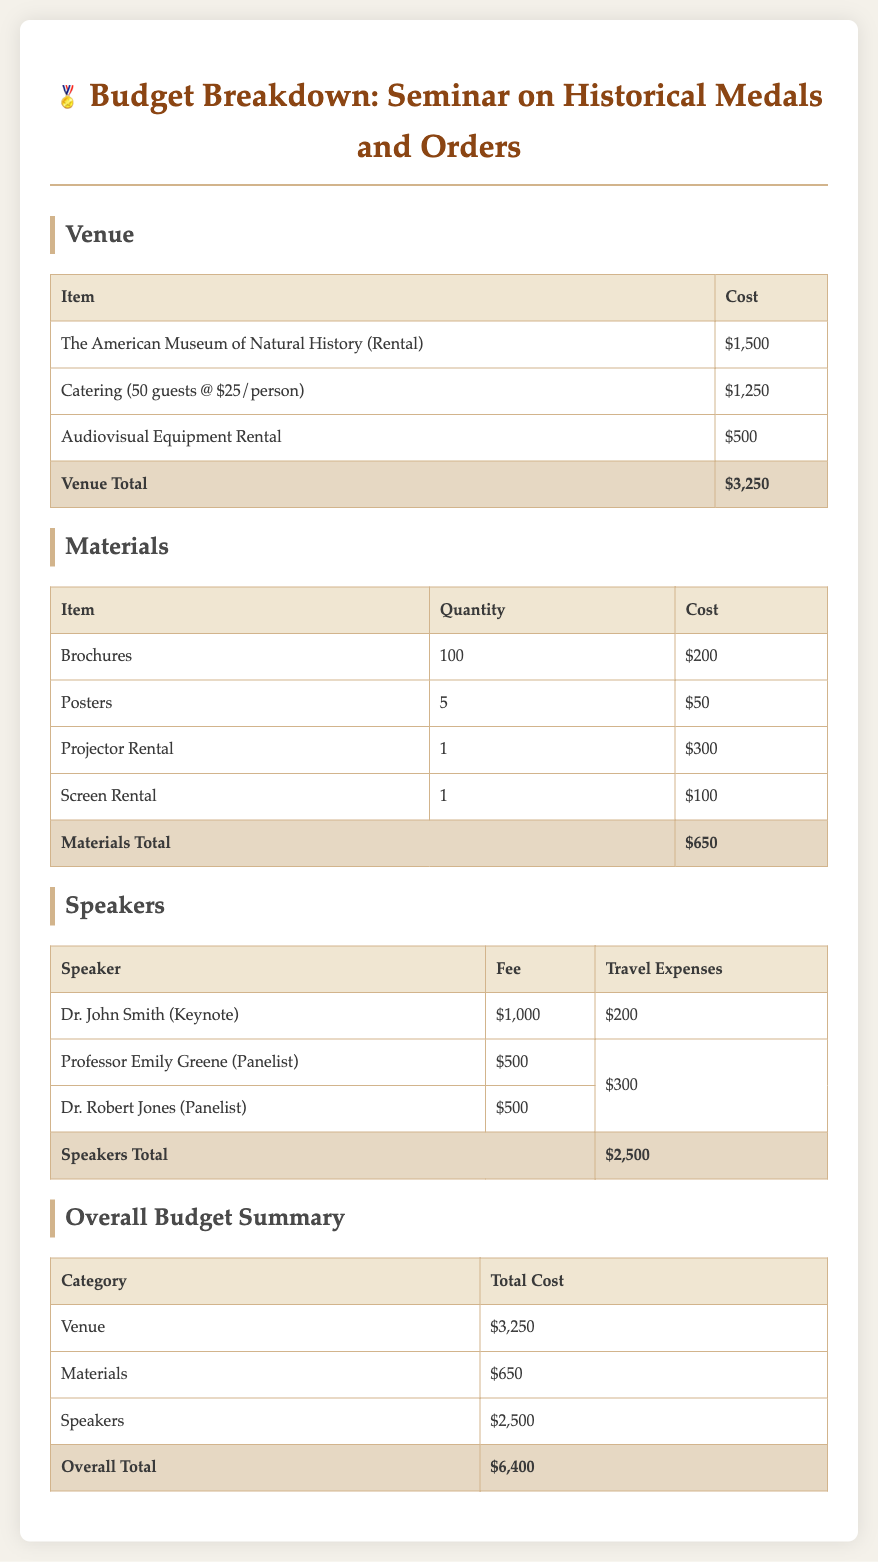What is the total cost for the venue? The total cost for the venue is listed at the bottom of the venue section, which is $3,250.
Answer: $3,250 How many guests are being catered? The catering cost is based on 50 guests, as mentioned in the venue cost breakdown.
Answer: 50 What is the fee for Dr. John Smith? Dr. John Smith's fee is specified in the speakers section, amounting to $1,000.
Answer: $1,000 What is the overall total budget for the seminar? The overall total budget is provided at the end of the overall budget summary, which adds up all categories.
Answer: $6,400 How much is allocated for materials? The materials total at the end of the materials section indicates the cost is $650.
Answer: $650 What is the travel expense for Professor Emily Greene? Professor Emily Greene's travel expense is presented in the speakers table, which is $300.
Answer: $300 How many brochures are planned for the seminar? The document states the quantity of brochures being printed is 100.
Answer: 100 What is the total cost allocated for speakers? The total cost for speakers is summarized at the end of the speakers section, totaling $2,500.
Answer: $2,500 What is the cost for audiovisual equipment rental? The cost for audiovisual equipment rental is specified in the venue section, which is $500.
Answer: $500 